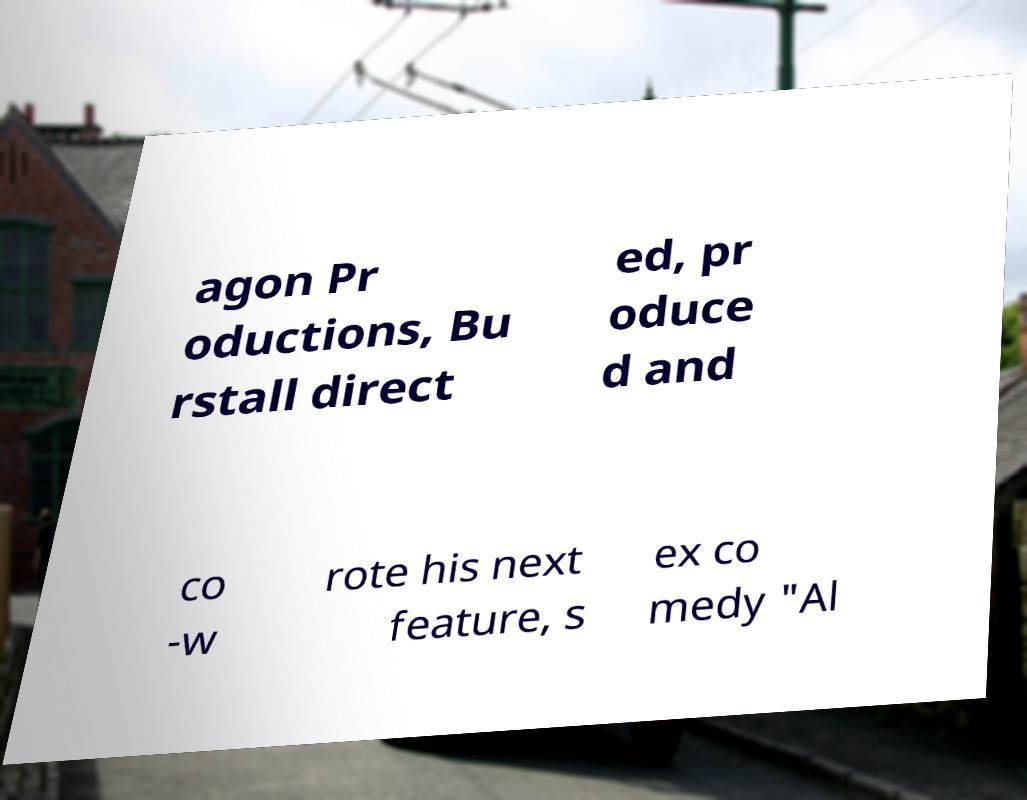I need the written content from this picture converted into text. Can you do that? agon Pr oductions, Bu rstall direct ed, pr oduce d and co -w rote his next feature, s ex co medy "Al 